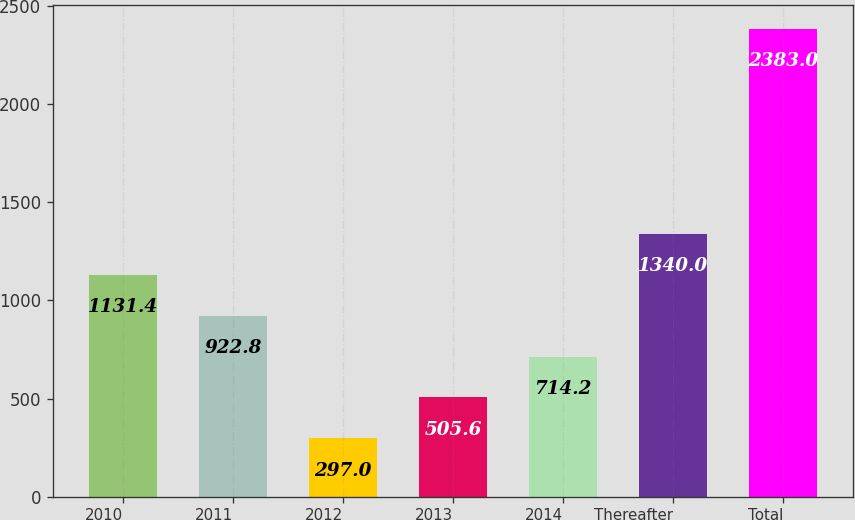<chart> <loc_0><loc_0><loc_500><loc_500><bar_chart><fcel>2010<fcel>2011<fcel>2012<fcel>2013<fcel>2014<fcel>Thereafter<fcel>Total<nl><fcel>1131.4<fcel>922.8<fcel>297<fcel>505.6<fcel>714.2<fcel>1340<fcel>2383<nl></chart> 